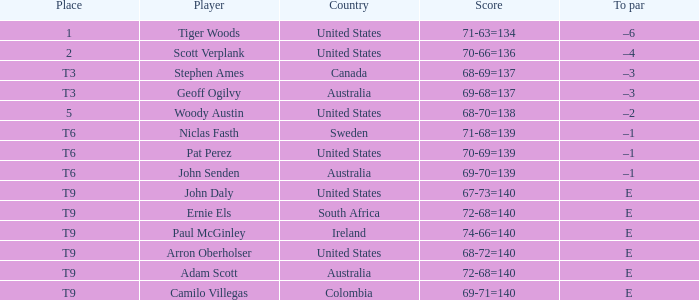Which player is from Sweden? Niclas Fasth. 